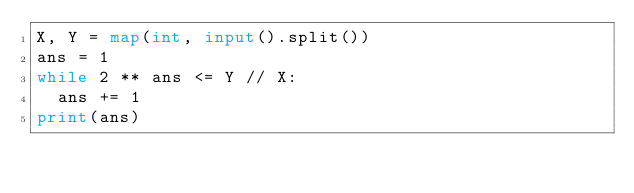<code> <loc_0><loc_0><loc_500><loc_500><_Python_>X, Y = map(int, input().split())
ans = 1
while 2 ** ans <= Y // X:
  ans += 1
print(ans)
</code> 